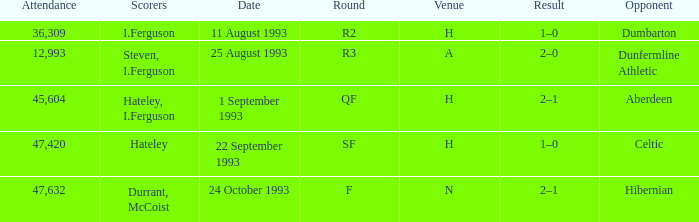What result is found for the round that has f? 2–1. 